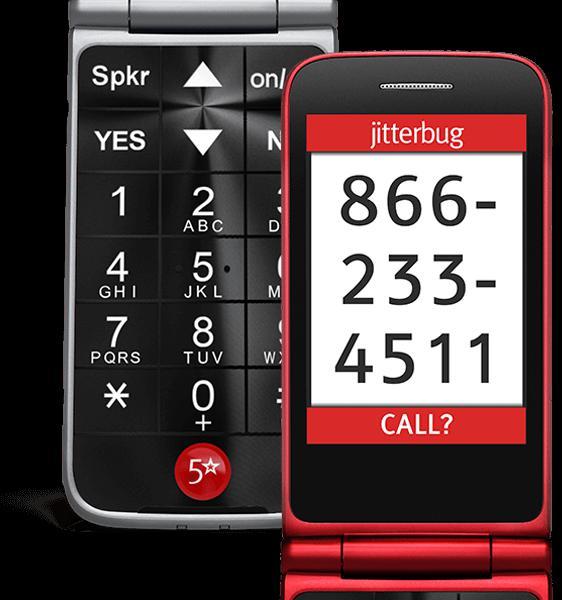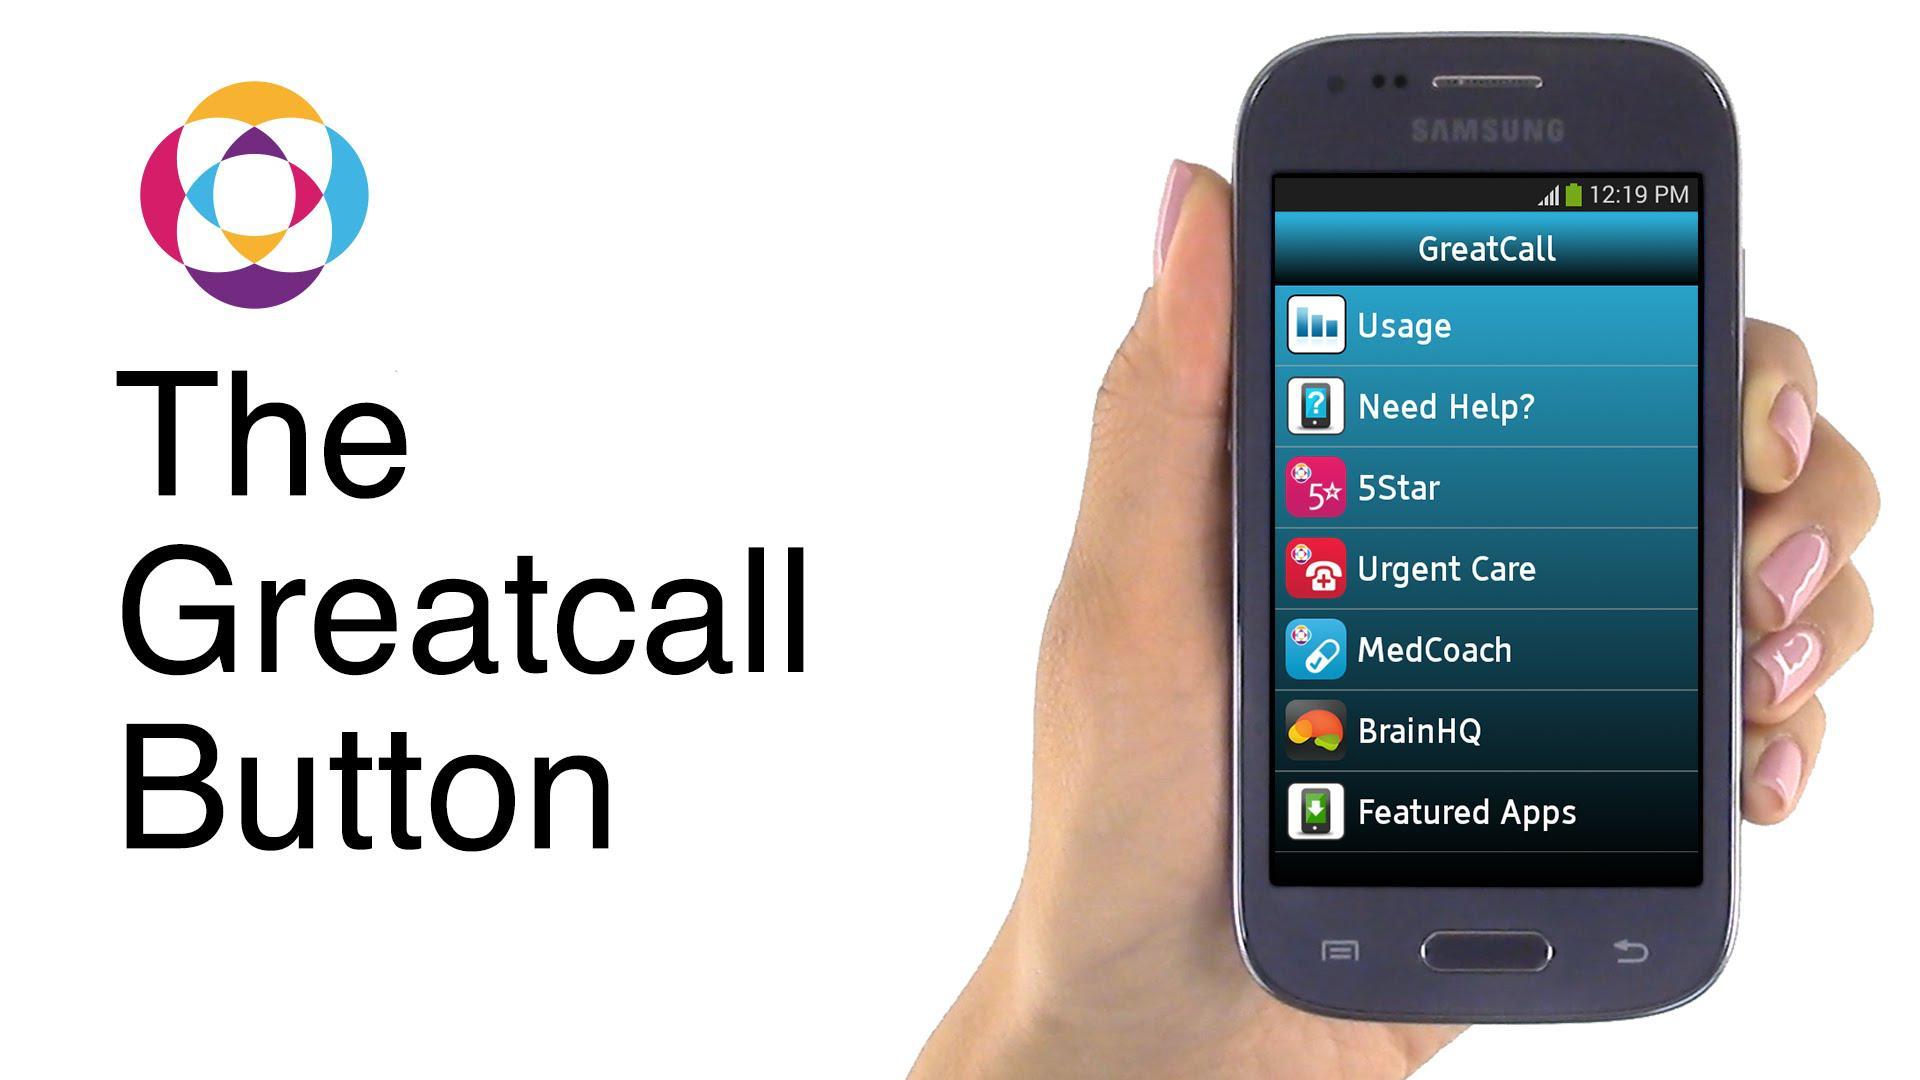The first image is the image on the left, the second image is the image on the right. Analyze the images presented: Is the assertion "In one image there is a red flip phone and in the other image there is a hand holding a grey and black phone." valid? Answer yes or no. Yes. The first image is the image on the left, the second image is the image on the right. Analyze the images presented: Is the assertion "An image shows a gray-haired man with one hand on his chin and a phone on the left." valid? Answer yes or no. No. 